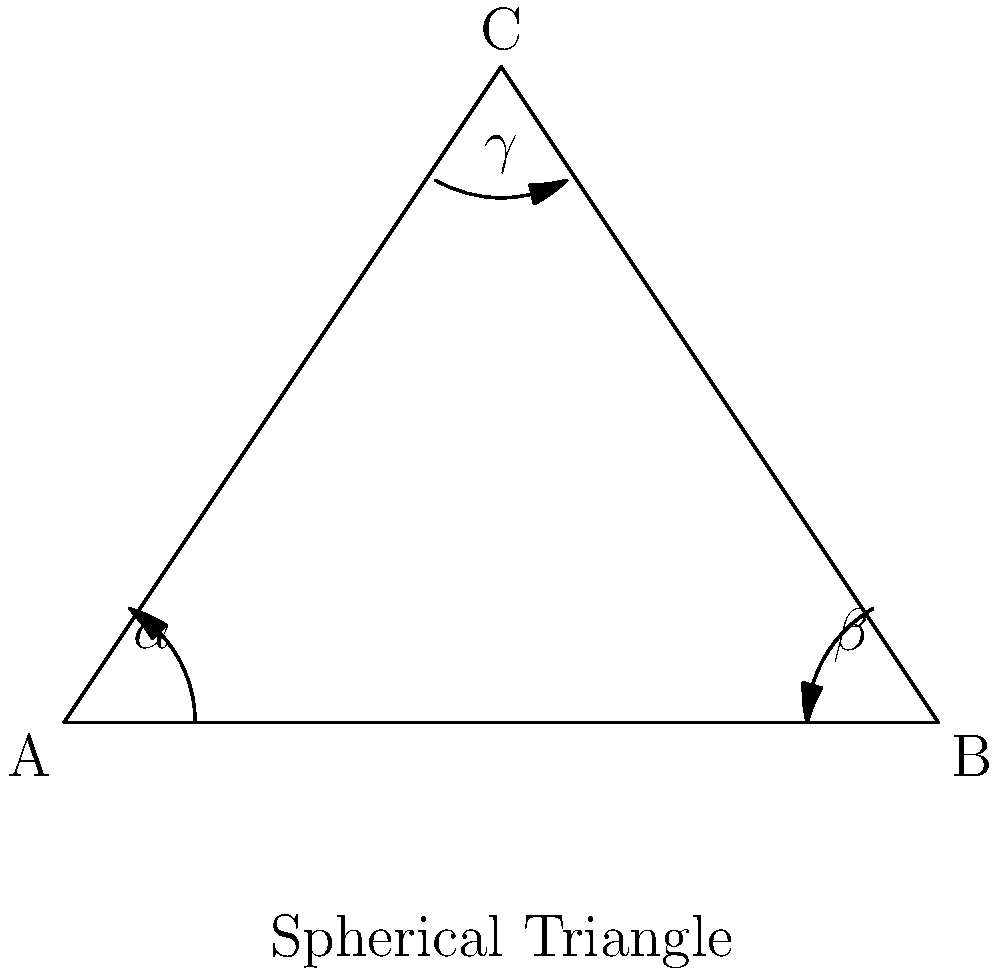In the context of non-Euclidean geometry, particularly on a sphere, how does the sum of the angles in a triangle relate to the area of the triangle and the radius of the sphere? Consider this in light of the divine perfection of God's creation. To understand this concept, let's approach it step-by-step:

1. In Euclidean geometry, the sum of angles in a triangle is always 180°. This reflects the perfection and consistency of God's creation in a flat plane.

2. However, on a sphere (a non-Euclidean surface), this rule changes, demonstrating the complexity and depth of God's design.

3. On a sphere, the sum of angles in a triangle is always greater than 180°. This excess is called the "spherical excess."

4. The relationship between the angles and the area of a spherical triangle is given by the Girard's Theorem:

   $$A + B + C = 180° + \frac{a}{R^2}$$

   Where $A$, $B$, and $C$ are the angles of the triangle, $a$ is the area of the triangle, and $R$ is the radius of the sphere.

5. Rearranging this equation:

   $$A + B + C - 180° = \frac{a}{R^2}$$

6. The left side of this equation is the spherical excess (E), so we can write:

   $$E = \frac{a}{R^2}$$

7. This means that the spherical excess is directly proportional to the area of the triangle and inversely proportional to the square of the sphere's radius.

8. As the area of the triangle increases, the sum of its angles increases above 180°.

9. As the radius of the sphere increases (approaching a flat plane), the sum of the angles approaches 180°.

This relationship reveals the intricate harmony in God's creation, showing how geometry adapts to different surfaces while maintaining mathematical consistency.
Answer: $E = \frac{a}{R^2}$, where E is spherical excess, a is triangle area, R is sphere radius. 